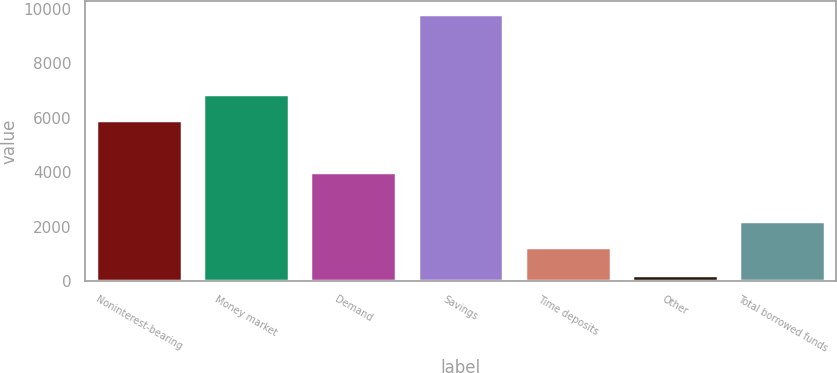Convert chart. <chart><loc_0><loc_0><loc_500><loc_500><bar_chart><fcel>Noninterest-bearing<fcel>Money market<fcel>Demand<fcel>Savings<fcel>Time deposits<fcel>Other<fcel>Total borrowed funds<nl><fcel>5904<fcel>6863.7<fcel>3998<fcel>9813<fcel>1246<fcel>216<fcel>2205.7<nl></chart> 